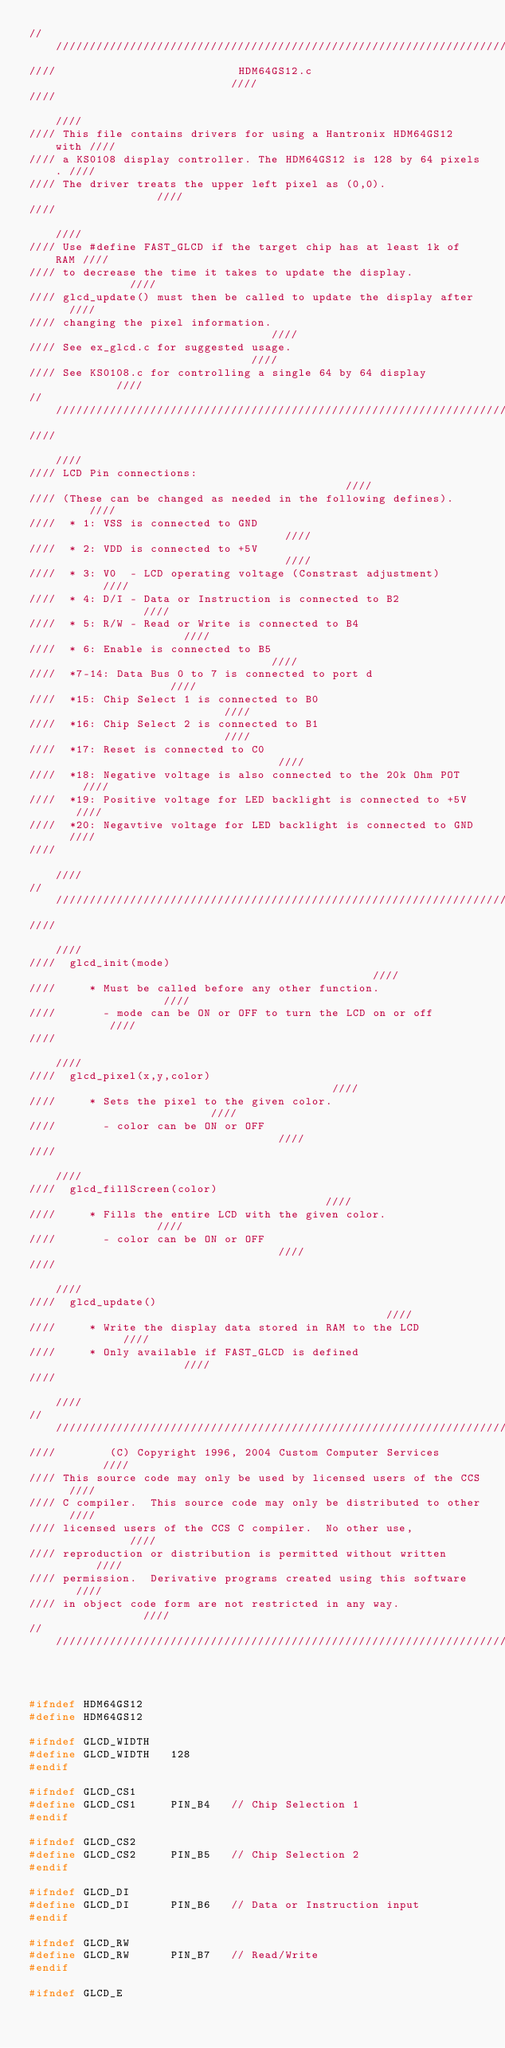<code> <loc_0><loc_0><loc_500><loc_500><_C_>/////////////////////////////////////////////////////////////////////////
////                           HDM64GS12.c                           ////
////                                                                 ////
//// This file contains drivers for using a Hantronix HDM64GS12 with ////
//// a KS0108 display controller. The HDM64GS12 is 128 by 64 pixels. ////
//// The driver treats the upper left pixel as (0,0).                ////
////                                                                 ////
//// Use #define FAST_GLCD if the target chip has at least 1k of RAM ////
//// to decrease the time it takes to update the display.            ////
//// glcd_update() must then be called to update the display after   ////
//// changing the pixel information.                                 ////
//// See ex_glcd.c for suggested usage.                              ////
//// See KS0108.c for controlling a single 64 by 64 display          ////
/////////////////////////////////////////////////////////////////////////
////                                                                 ////
//// LCD Pin connections:                                            ////
//// (These can be changed as needed in the following defines).      ////
////  * 1: VSS is connected to GND                                   ////
////  * 2: VDD is connected to +5V                                   ////
////  * 3: V0  - LCD operating voltage (Constrast adjustment)        ////
////  * 4: D/I - Data or Instruction is connected to B2              ////
////  * 5: R/W - Read or Write is connected to B4                    ////
////  * 6: Enable is connected to B5                                 ////
////  *7-14: Data Bus 0 to 7 is connected to port d                  ////
////  *15: Chip Select 1 is connected to B0                          ////
////  *16: Chip Select 2 is connected to B1                          ////
////  *17: Reset is connected to C0                                  ////
////  *18: Negative voltage is also connected to the 20k Ohm POT     ////
////  *19: Positive voltage for LED backlight is connected to +5V    ////
////  *20: Negavtive voltage for LED backlight is connected to GND   ////
////                                                                 ////
/////////////////////////////////////////////////////////////////////////
////                                                                 ////
////  glcd_init(mode)                                                ////
////     * Must be called before any other function.                 ////
////       - mode can be ON or OFF to turn the LCD on or off         ////
////                                                                 ////
////  glcd_pixel(x,y,color)                                          ////
////     * Sets the pixel to the given color.                        ////
////       - color can be ON or OFF                                  ////
////                                                                 ////
////  glcd_fillScreen(color)                                         ////
////     * Fills the entire LCD with the given color.                ////
////       - color can be ON or OFF                                  ////
////                                                                 ////
////  glcd_update()                                                  ////
////     * Write the display data stored in RAM to the LCD           ////
////     * Only available if FAST_GLCD is defined                    ////
////                                                                 ////
/////////////////////////////////////////////////////////////////////////
////        (C) Copyright 1996, 2004 Custom Computer Services        ////
//// This source code may only be used by licensed users of the CCS  ////
//// C compiler.  This source code may only be distributed to other  ////
//// licensed users of the CCS C compiler.  No other use,            ////
//// reproduction or distribution is permitted without written       ////
//// permission.  Derivative programs created using this software    ////
//// in object code form are not restricted in any way.              ////
/////////////////////////////////////////////////////////////////////////



#ifndef HDM64GS12
#define HDM64GS12

#ifndef GLCD_WIDTH
#define GLCD_WIDTH   128
#endif

#ifndef GLCD_CS1
#define GLCD_CS1     PIN_B4   // Chip Selection 1
#endif

#ifndef GLCD_CS2
#define GLCD_CS2     PIN_B5   // Chip Selection 2
#endif

#ifndef GLCD_DI
#define GLCD_DI      PIN_B6   // Data or Instruction input
#endif

#ifndef GLCD_RW
#define GLCD_RW      PIN_B7   // Read/Write
#endif

#ifndef GLCD_E</code> 